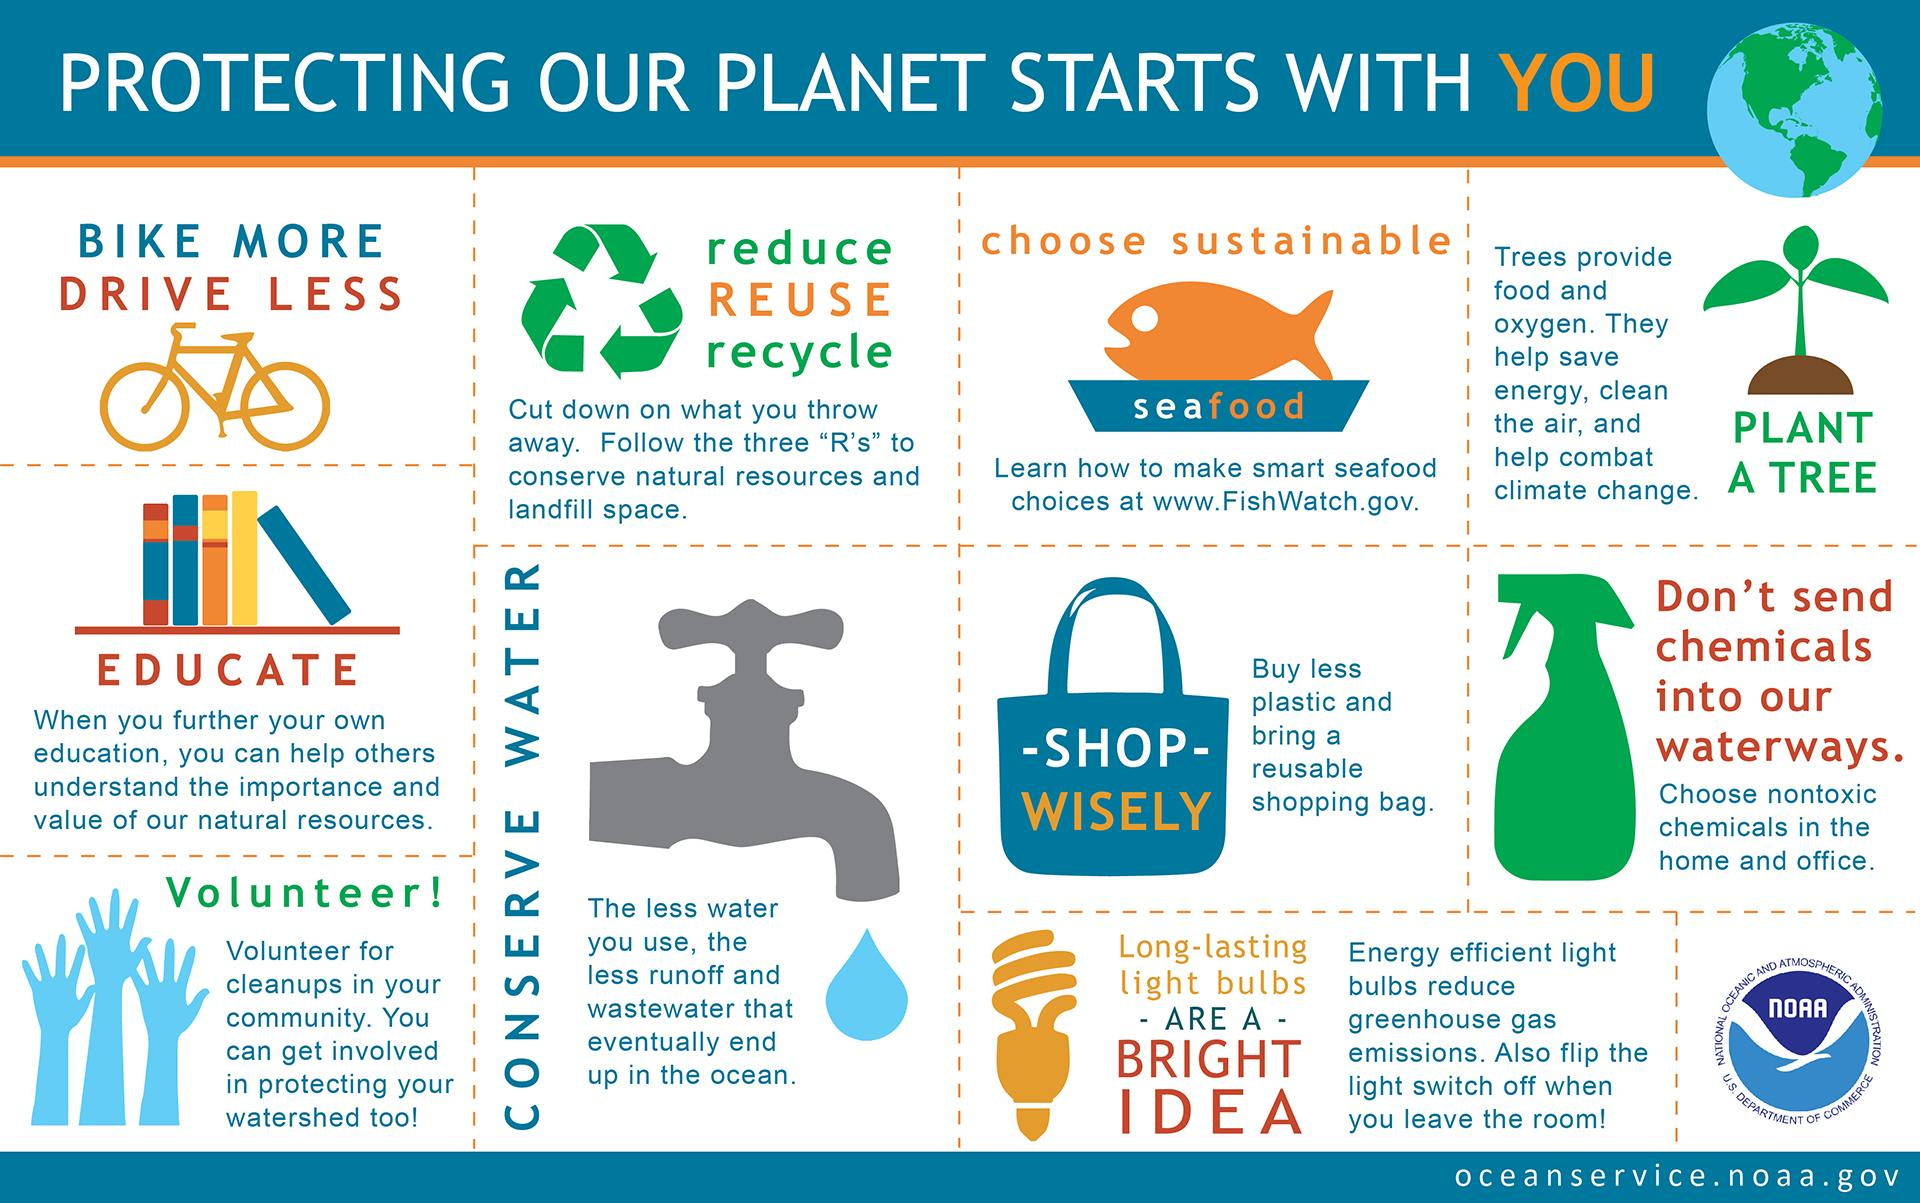Identify some key points in this picture. Cycling is the mode of transportation that does not produce any carbon footprints, as it is a clean and environmentally friendly means of travel. Seafood is considered to be environmentally friendly. To address the destruction of natural resources, it is essential to adopt a three-step approach: reduce, reuse, and recycle. 